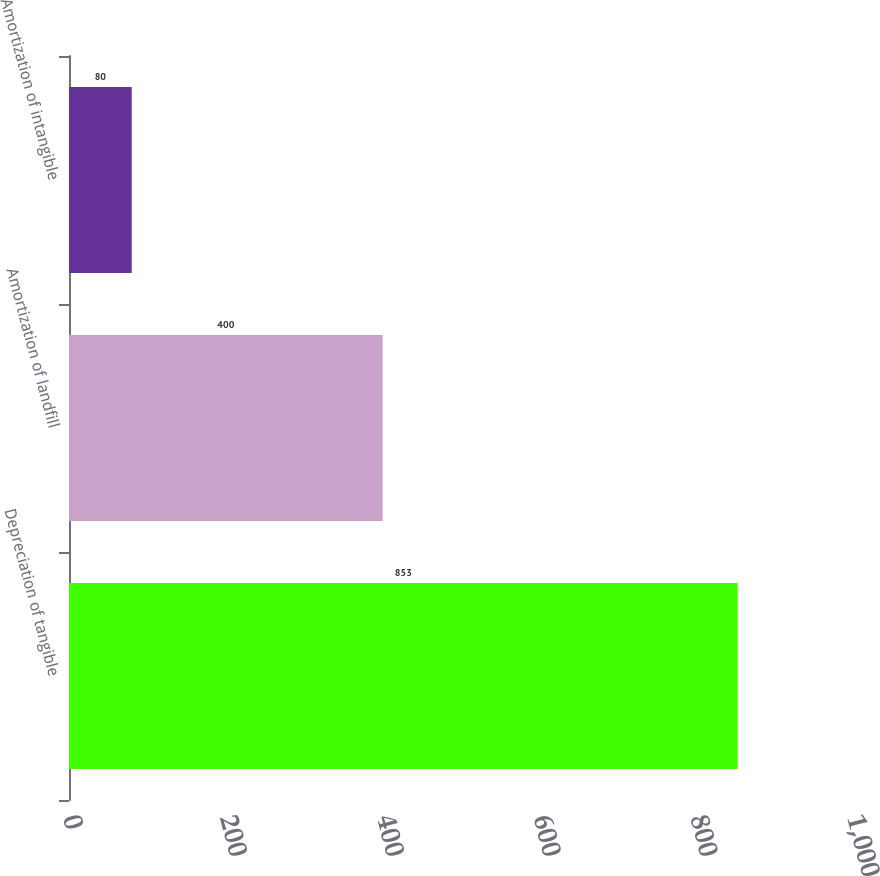Convert chart. <chart><loc_0><loc_0><loc_500><loc_500><bar_chart><fcel>Depreciation of tangible<fcel>Amortization of landfill<fcel>Amortization of intangible<nl><fcel>853<fcel>400<fcel>80<nl></chart> 